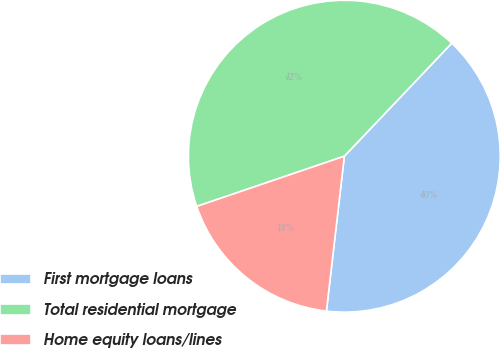Convert chart to OTSL. <chart><loc_0><loc_0><loc_500><loc_500><pie_chart><fcel>First mortgage loans<fcel>Total residential mortgage<fcel>Home equity loans/lines<nl><fcel>39.74%<fcel>42.31%<fcel>17.95%<nl></chart> 